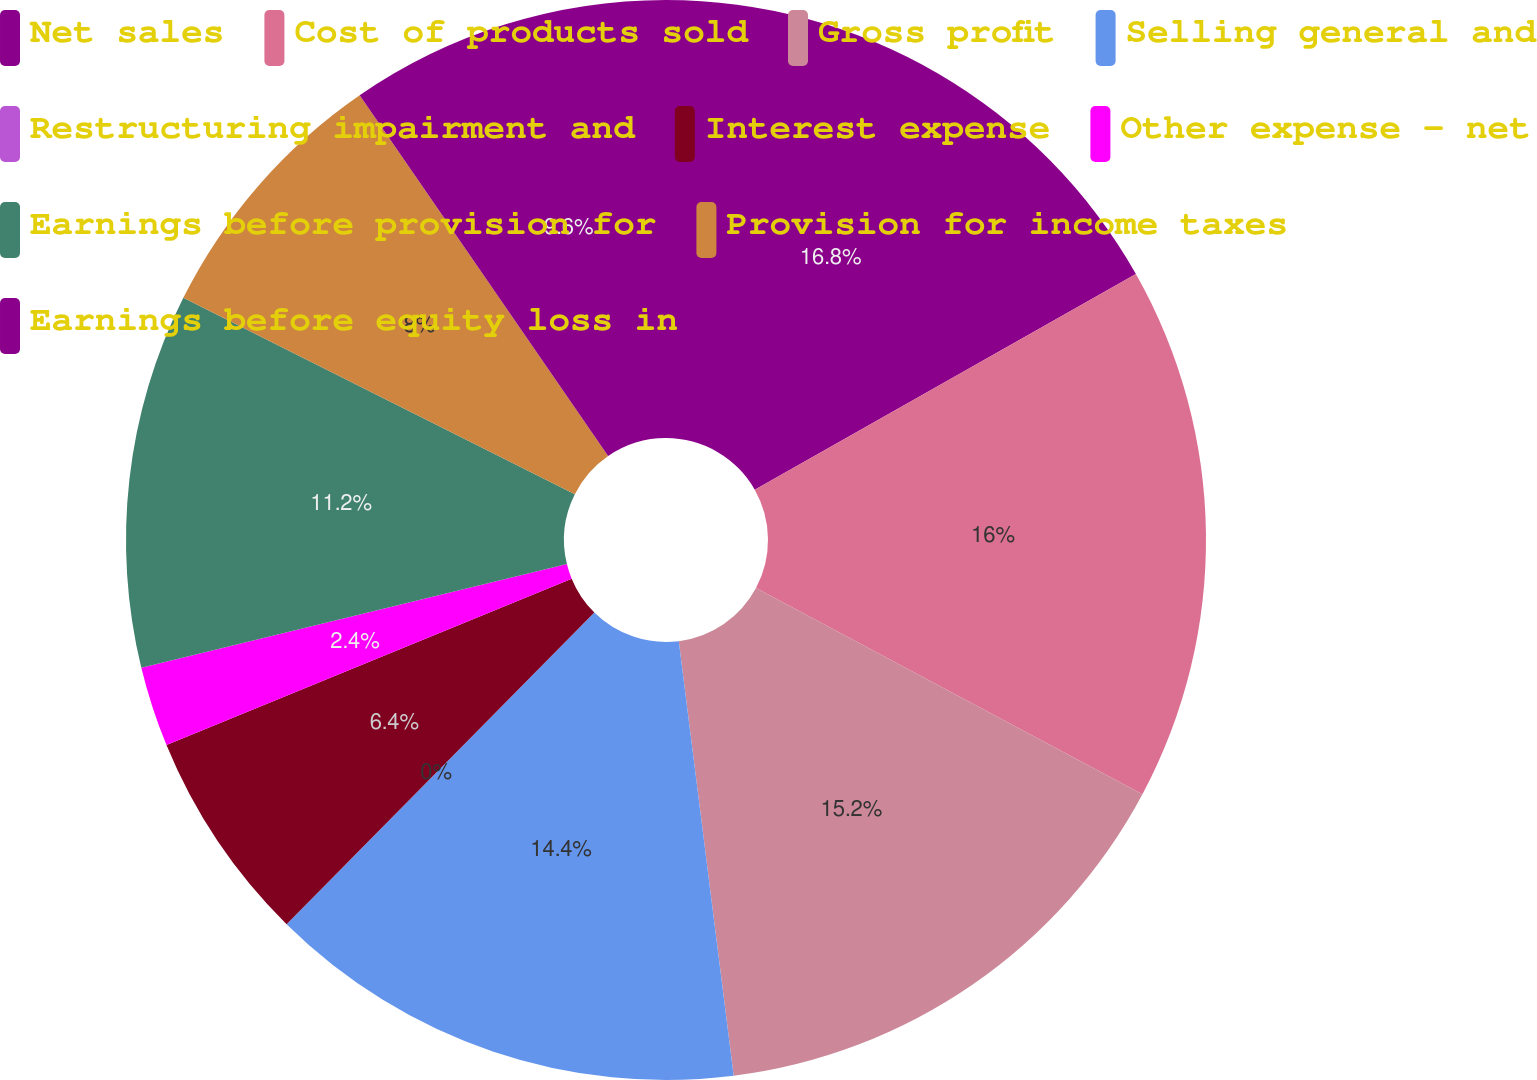<chart> <loc_0><loc_0><loc_500><loc_500><pie_chart><fcel>Net sales<fcel>Cost of products sold<fcel>Gross profit<fcel>Selling general and<fcel>Restructuring impairment and<fcel>Interest expense<fcel>Other expense - net<fcel>Earnings before provision for<fcel>Provision for income taxes<fcel>Earnings before equity loss in<nl><fcel>16.8%<fcel>16.0%<fcel>15.2%<fcel>14.4%<fcel>0.0%<fcel>6.4%<fcel>2.4%<fcel>11.2%<fcel>8.0%<fcel>9.6%<nl></chart> 